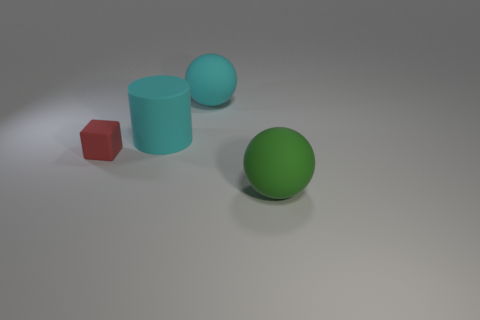Add 1 matte cylinders. How many objects exist? 5 Subtract all green balls. How many balls are left? 1 Subtract all cylinders. How many objects are left? 3 Subtract all brown cylinders. Subtract all green spheres. How many cylinders are left? 1 Subtract all yellow spheres. How many blue cylinders are left? 0 Subtract all blue metallic cylinders. Subtract all red rubber objects. How many objects are left? 3 Add 1 tiny blocks. How many tiny blocks are left? 2 Add 3 red blocks. How many red blocks exist? 4 Subtract 0 red cylinders. How many objects are left? 4 